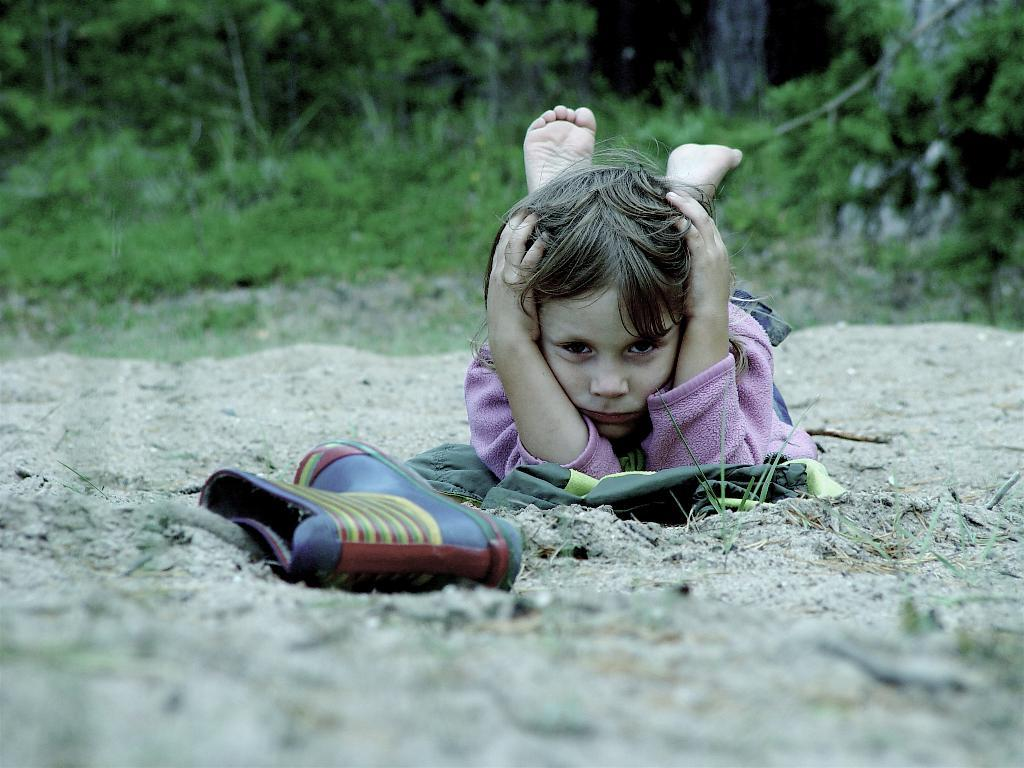What object can be seen in the image? There is a shoe in the image. What is the person in the image doing? There is a person lying on the sand in the image. What can be seen in the background of the image? There are trees and plants in the background of the image. How many eggs are visible in the image? There are no eggs present in the image. What type of growth can be observed in the image? The image does not depict any growth or development; it features a shoe, a person lying on the sand, and trees and plants in the background. 